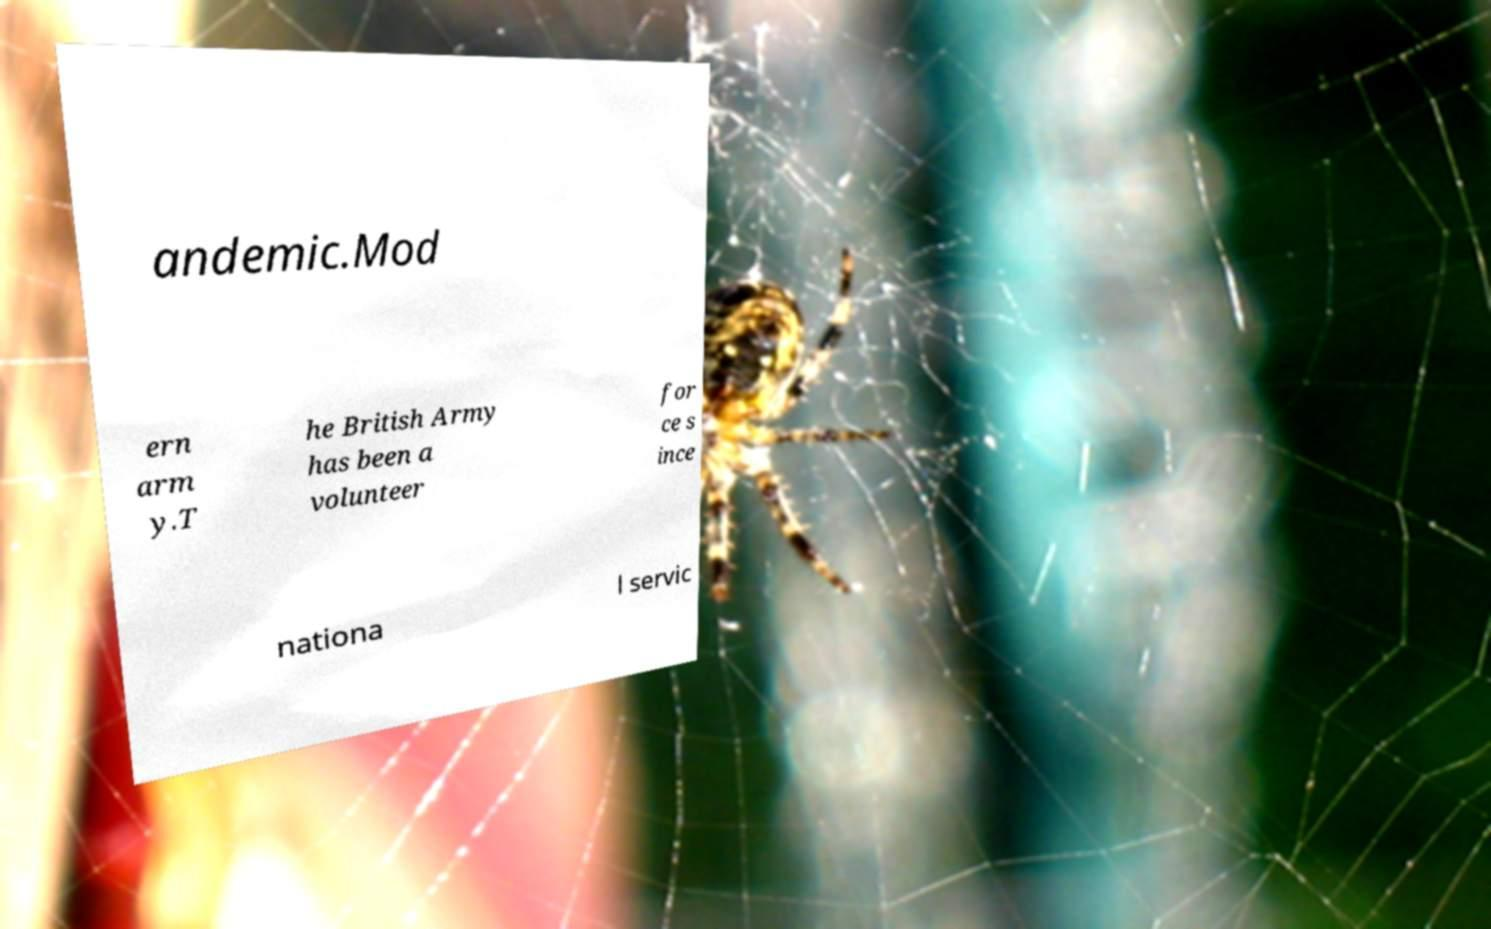Could you assist in decoding the text presented in this image and type it out clearly? andemic.Mod ern arm y.T he British Army has been a volunteer for ce s ince nationa l servic 